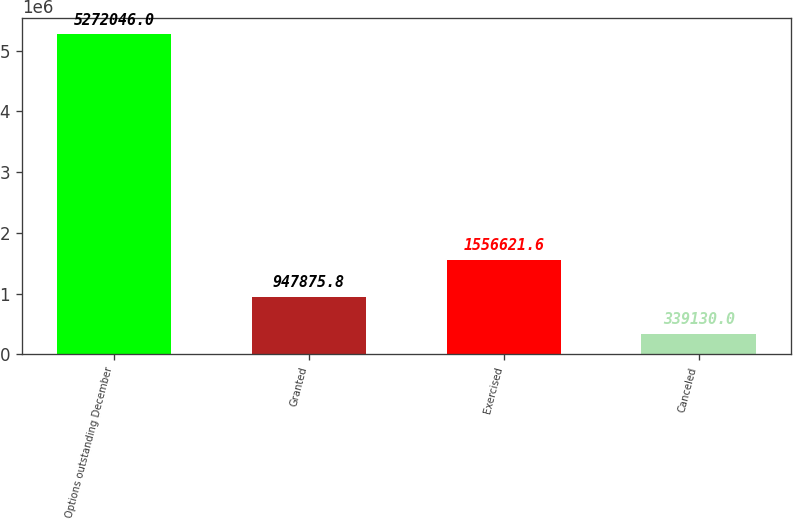Convert chart to OTSL. <chart><loc_0><loc_0><loc_500><loc_500><bar_chart><fcel>Options outstanding December<fcel>Granted<fcel>Exercised<fcel>Canceled<nl><fcel>5.27205e+06<fcel>947876<fcel>1.55662e+06<fcel>339130<nl></chart> 